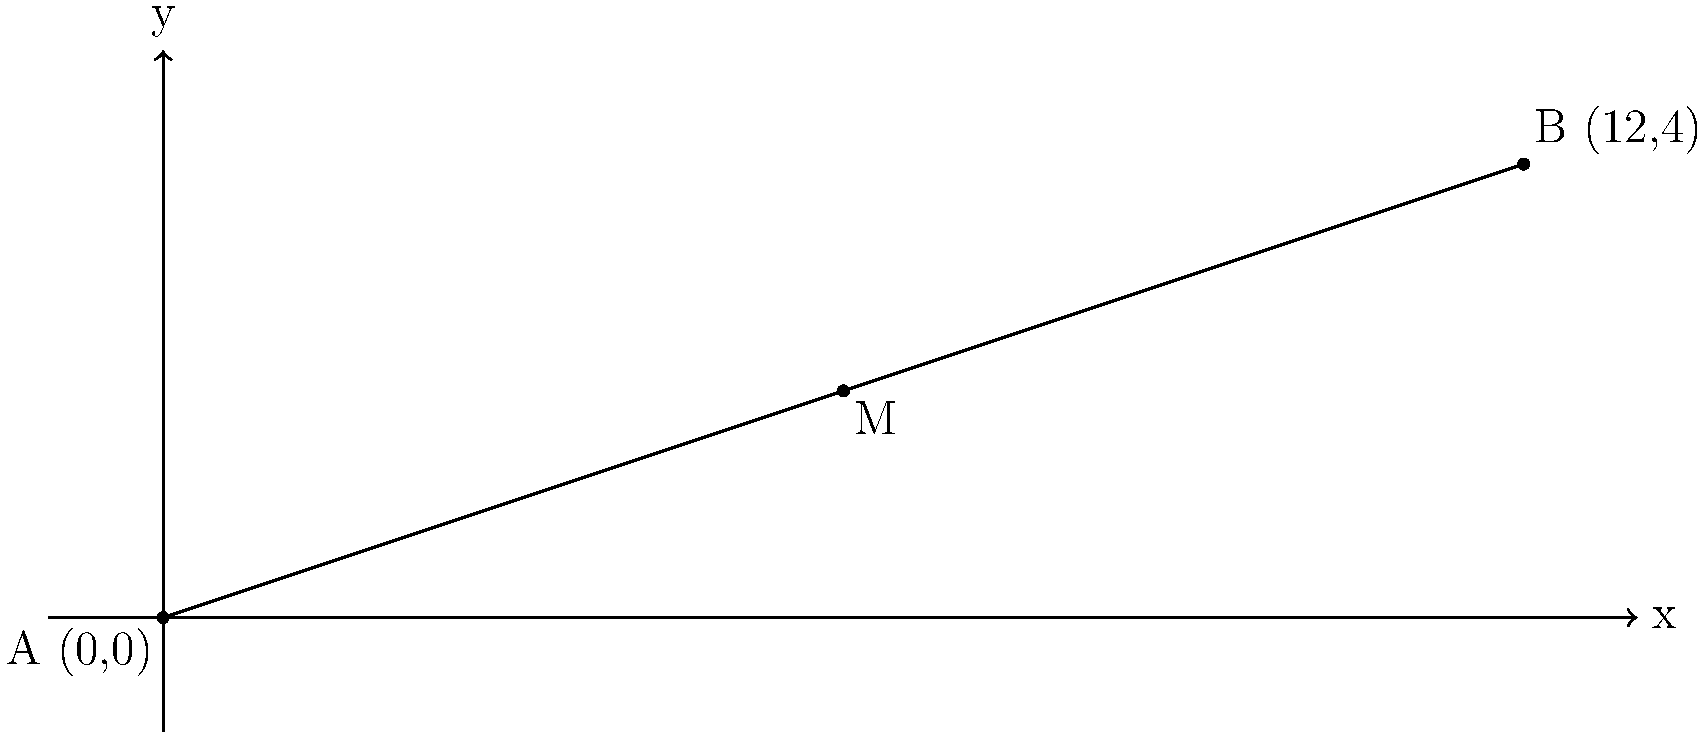The Anthem STR Integrated Amplifier has a sleek soundbar that stretches from point A (0,0) to point B (12,4) on a coordinate plane, where each unit represents 5 cm. Find the coordinates of the midpoint M of this soundbar. To find the midpoint of a line segment, we use the midpoint formula:

$$ M = \left(\frac{x_1 + x_2}{2}, \frac{y_1 + y_2}{2}\right) $$

Where $(x_1, y_1)$ are the coordinates of point A, and $(x_2, y_2)$ are the coordinates of point B.

Given:
- Point A: (0,0)
- Point B: (12,4)

Step 1: Calculate the x-coordinate of the midpoint:
$$ x = \frac{x_1 + x_2}{2} = \frac{0 + 12}{2} = \frac{12}{2} = 6 $$

Step 2: Calculate the y-coordinate of the midpoint:
$$ y = \frac{y_1 + y_2}{2} = \frac{0 + 4}{2} = \frac{4}{2} = 2 $$

Therefore, the coordinates of the midpoint M are (6,2).

Note: Since each unit represents 5 cm, the actual midpoint of the soundbar is at 30 cm (6 × 5 cm) along the x-axis and 10 cm (2 × 5 cm) along the y-axis from point A.
Answer: (6,2) 